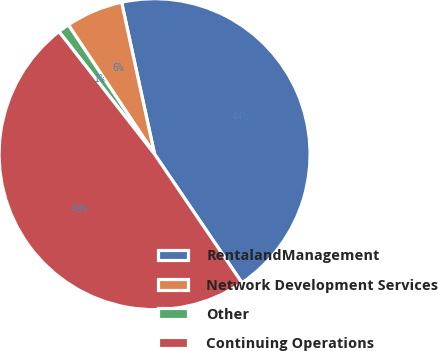<chart> <loc_0><loc_0><loc_500><loc_500><pie_chart><fcel>RentalandManagement<fcel>Network Development Services<fcel>Other<fcel>Continuing Operations<nl><fcel>43.91%<fcel>5.96%<fcel>1.18%<fcel>48.96%<nl></chart> 